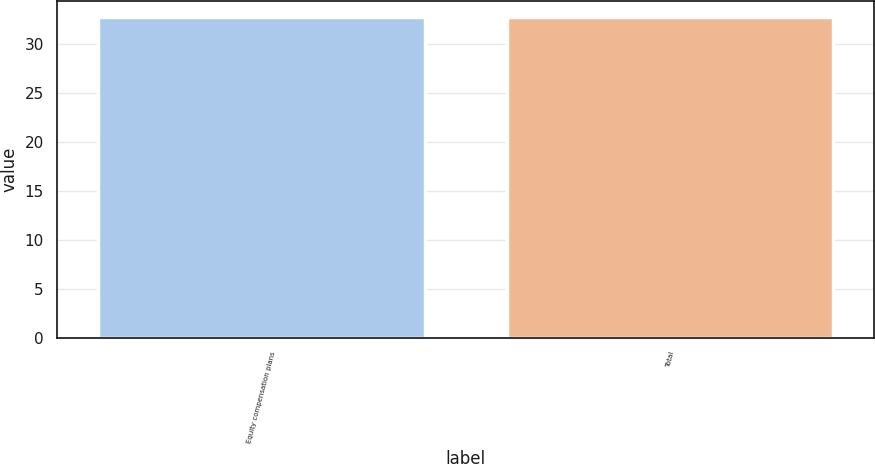Convert chart to OTSL. <chart><loc_0><loc_0><loc_500><loc_500><bar_chart><fcel>Equity compensation plans<fcel>Total<nl><fcel>32.76<fcel>32.72<nl></chart> 